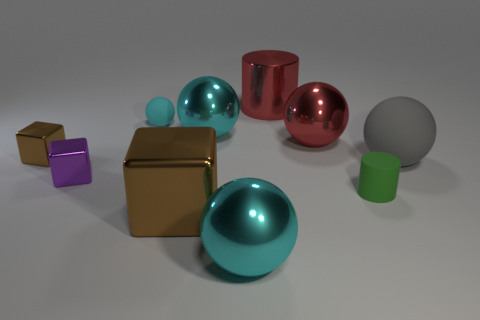Subtract all cyan balls. How many were subtracted if there are1cyan balls left? 2 Subtract all purple cylinders. How many cyan spheres are left? 3 Subtract 3 spheres. How many spheres are left? 2 Subtract all large blocks. How many blocks are left? 2 Subtract all red balls. How many balls are left? 4 Subtract all blue spheres. Subtract all cyan cylinders. How many spheres are left? 5 Subtract all cylinders. How many objects are left? 8 Add 9 small purple rubber cubes. How many small purple rubber cubes exist? 9 Subtract 0 purple cylinders. How many objects are left? 10 Subtract all large gray metal cylinders. Subtract all big red metallic cylinders. How many objects are left? 9 